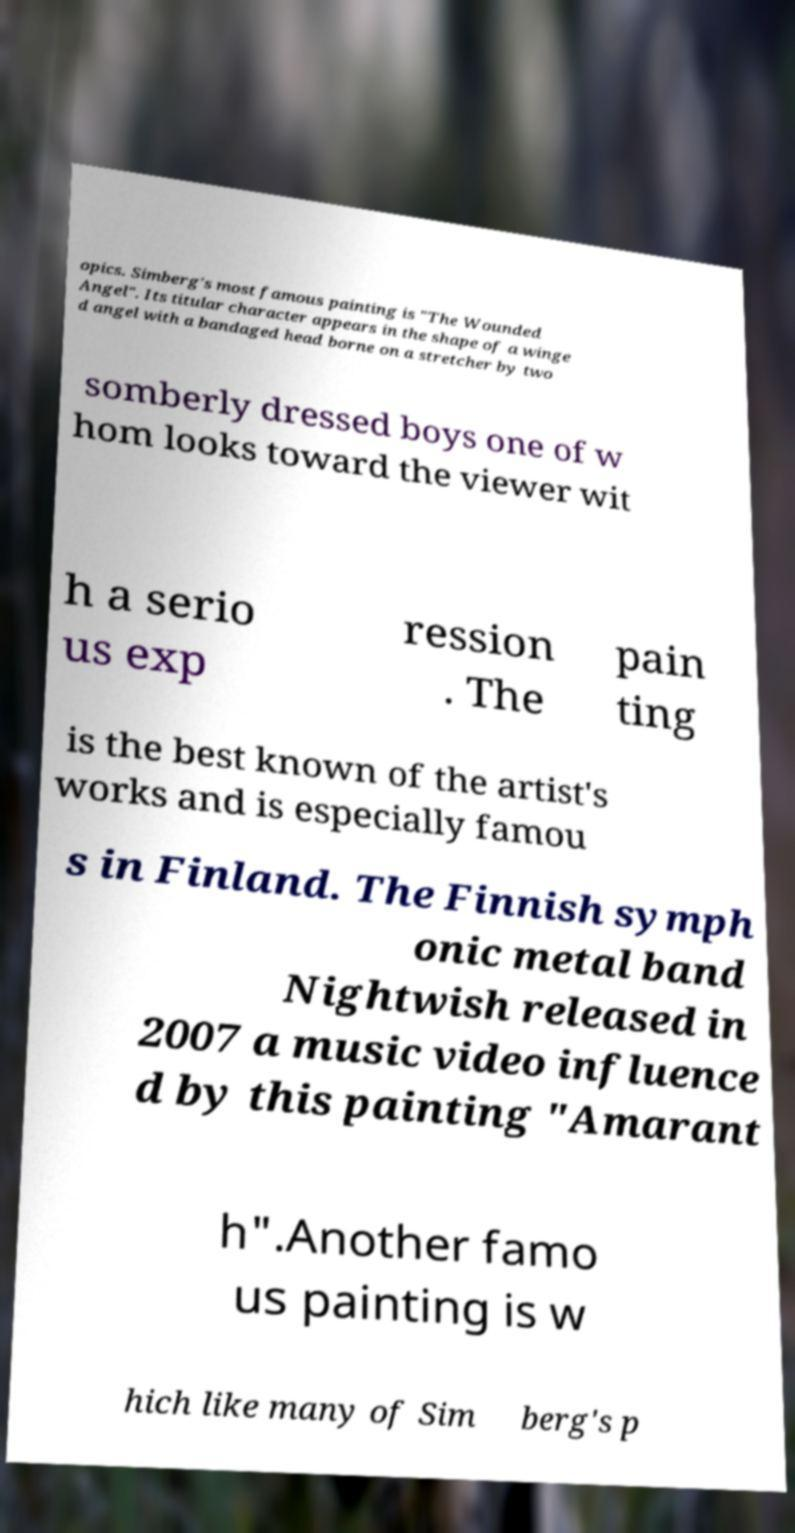Please identify and transcribe the text found in this image. opics. Simberg's most famous painting is "The Wounded Angel". Its titular character appears in the shape of a winge d angel with a bandaged head borne on a stretcher by two somberly dressed boys one of w hom looks toward the viewer wit h a serio us exp ression . The pain ting is the best known of the artist's works and is especially famou s in Finland. The Finnish symph onic metal band Nightwish released in 2007 a music video influence d by this painting "Amarant h".Another famo us painting is w hich like many of Sim berg's p 